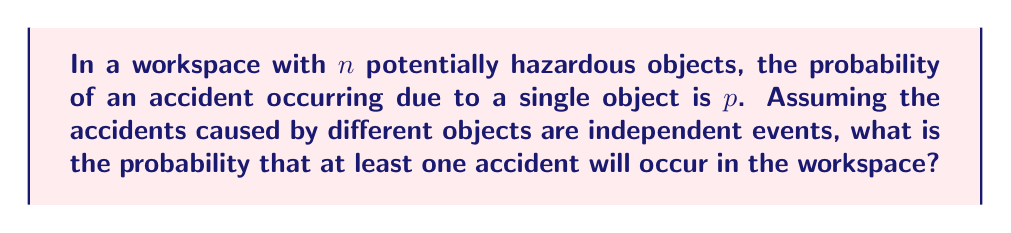Provide a solution to this math problem. Let's approach this step-by-step:

1) First, let's consider the probability of no accidents occurring:
   - For a single object, the probability of no accident is $(1-p)$
   - For $n$ independent objects, the probability of no accidents is $(1-p)^n$

2) The probability of at least one accident occurring is the complement of the probability of no accidents:

   $$P(\text{at least one accident}) = 1 - P(\text{no accidents})$$

3) Substituting the probability we found in step 1:

   $$P(\text{at least one accident}) = 1 - (1-p)^n$$

4) This formula gives us the probability of at least one accident occurring in a workspace with $n$ hazardous objects, where each object has a probability $p$ of causing an accident.

5) For example, if we have 5 hazardous objects $(n=5)$ and each has a 10% chance of causing an accident $(p=0.1)$, the probability of at least one accident would be:

   $$1 - (1-0.1)^5 = 1 - (0.9)^5 \approx 0.4095 \text{ or about } 41\%$$

This formula allows for quick estimation of accident probability based on the number of hazardous objects present, which is crucial for maintaining workplace safety.
Answer: $1 - (1-p)^n$ 